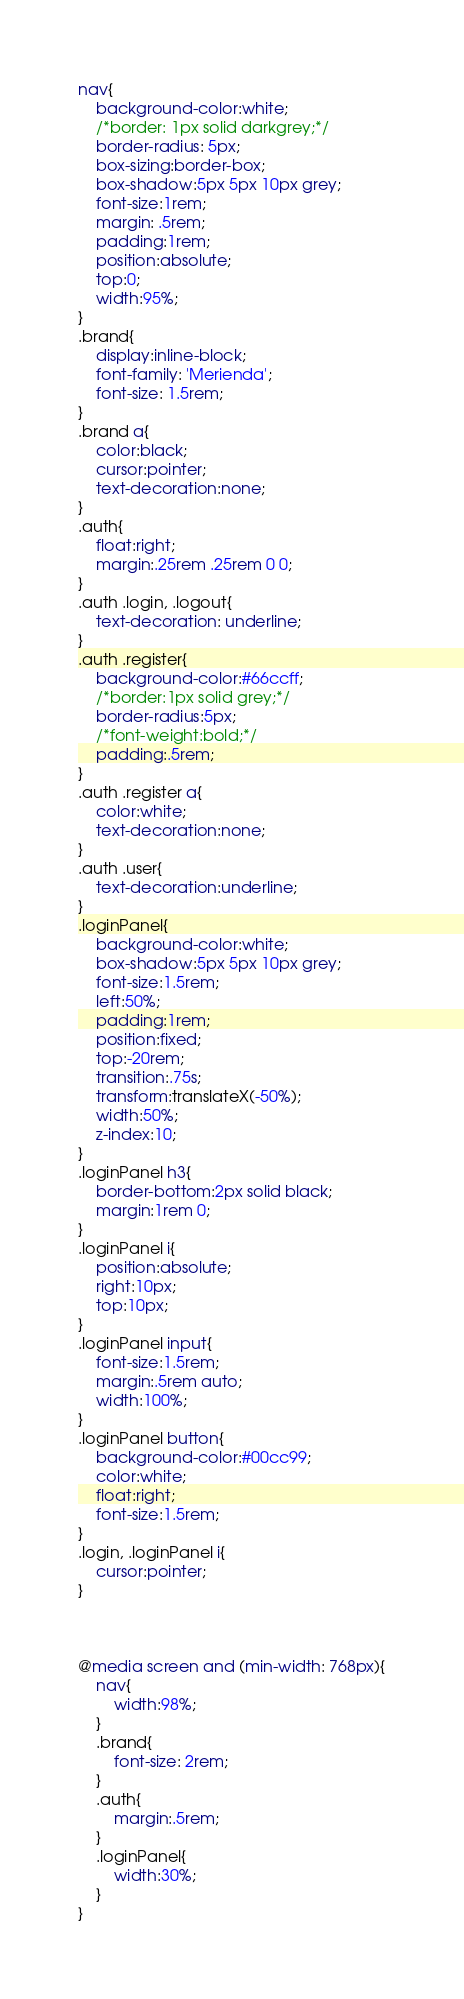Convert code to text. <code><loc_0><loc_0><loc_500><loc_500><_CSS_>nav{
    background-color:white;
    /*border: 1px solid darkgrey;*/
    border-radius: 5px;
    box-sizing:border-box;
    box-shadow:5px 5px 10px grey;
    font-size:1rem;
    margin: .5rem;
    padding:1rem;
    position:absolute;
    top:0;
    width:95%;
}
.brand{
    display:inline-block;
    font-family: 'Merienda';
    font-size: 1.5rem;
}
.brand a{
    color:black;
    cursor:pointer;
    text-decoration:none;
}
.auth{
    float:right;
    margin:.25rem .25rem 0 0;
}
.auth .login, .logout{
    text-decoration: underline;
}
.auth .register{
    background-color:#66ccff;
    /*border:1px solid grey;*/
    border-radius:5px;
    /*font-weight:bold;*/
    padding:.5rem;
}
.auth .register a{
    color:white;
    text-decoration:none;
}
.auth .user{
    text-decoration:underline;
}
.loginPanel{
    background-color:white;
    box-shadow:5px 5px 10px grey;
    font-size:1.5rem;
    left:50%;
    padding:1rem;
    position:fixed;
    top:-20rem;
    transition:.75s;
    transform:translateX(-50%);
    width:50%;
    z-index:10;
}
.loginPanel h3{
    border-bottom:2px solid black;
    margin:1rem 0;
}
.loginPanel i{
    position:absolute;
    right:10px;
    top:10px;
}
.loginPanel input{
    font-size:1.5rem;
    margin:.5rem auto;
    width:100%;
}
.loginPanel button{
    background-color:#00cc99;
    color:white;
    float:right;
    font-size:1.5rem;
}
.login, .loginPanel i{
    cursor:pointer;
}



@media screen and (min-width: 768px){
    nav{
        width:98%;
    }
    .brand{
        font-size: 2rem;
    }
    .auth{
        margin:.5rem;
    }
    .loginPanel{
        width:30%;
    }
}</code> 